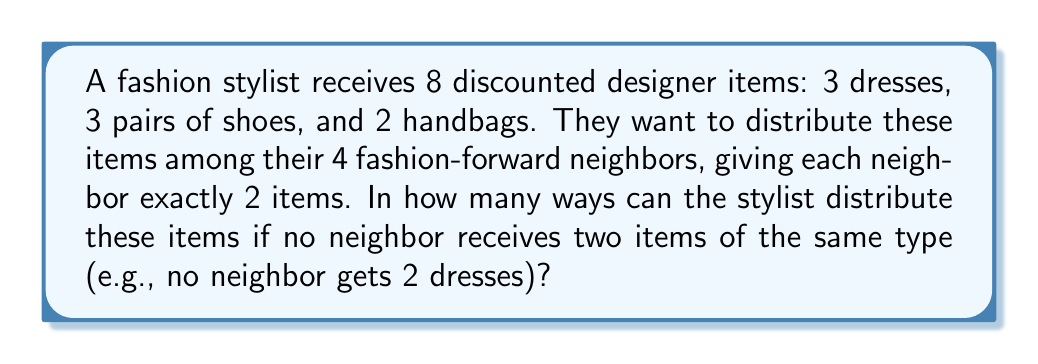Give your solution to this math problem. Let's approach this step-by-step:

1) First, we need to choose which 2 of the 4 neighbors will receive dresses. This can be done in $\binom{4}{2} = 6$ ways.

2) For these 2 neighbors, we need to distribute the 3 dresses. This can be done in $3 \cdot 2 = 6$ ways.

3) Now, we need to choose which of the remaining 2 neighbors will receive shoes. This can be done in $\binom{2}{1} = 2$ ways.

4) For these 2 neighbors (the one we just chose and one of the dress recipients), we need to distribute 2 of the 3 pairs of shoes. This can be done in $3 \cdot 2 = 6$ ways.

5) The last neighbor will receive the remaining pair of shoes and one of the handbags. There are 2 handbags to choose from.

6) By the multiplication principle, the total number of ways to distribute the items is:

   $$6 \cdot 6 \cdot 2 \cdot 6 \cdot 2 = 864$$

Therefore, there are 864 ways to distribute the items among the neighbors.
Answer: 864 